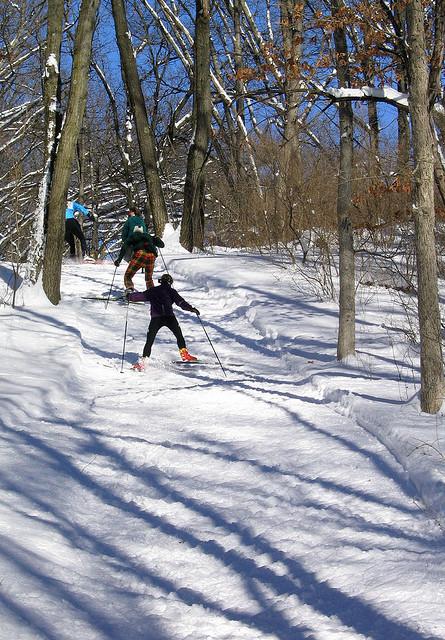Is that a child?
Answer briefly. Yes. Is cold here?
Give a very brief answer. Yes. Is the sky blue?
Concise answer only. Yes. Is this person going fast?
Be succinct. No. 